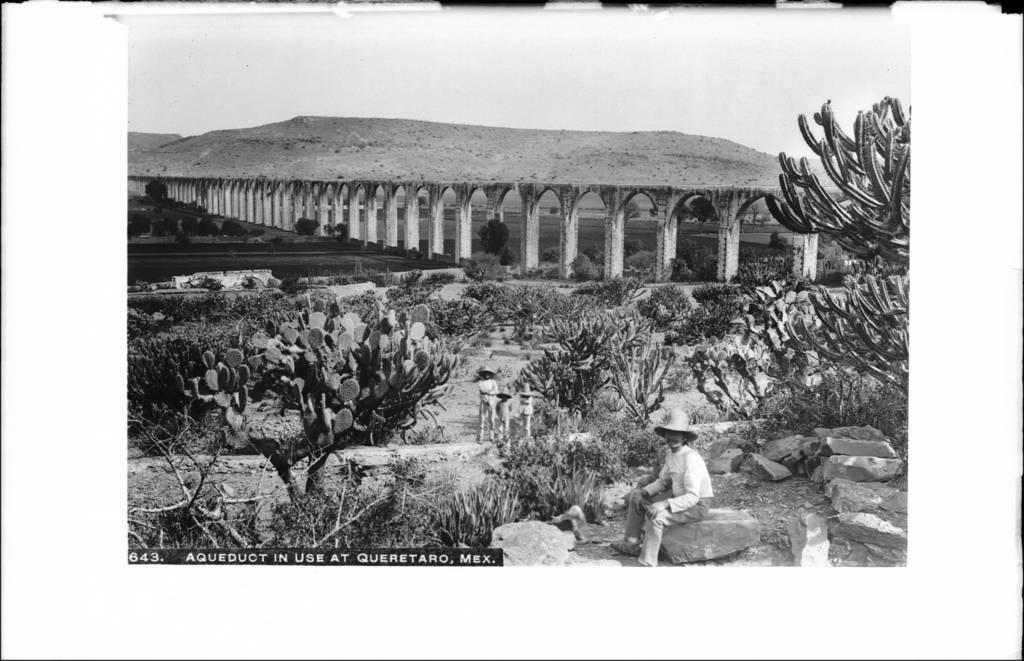Describe this image in one or two sentences. This picture is black and white. In the center of the image we can see three persons are standing and wearing hat. In the background of the image we can see bridge, hills, bushes, ground. At the bottom of the image we can see a person is sitting on a stone and wearing a hat. 